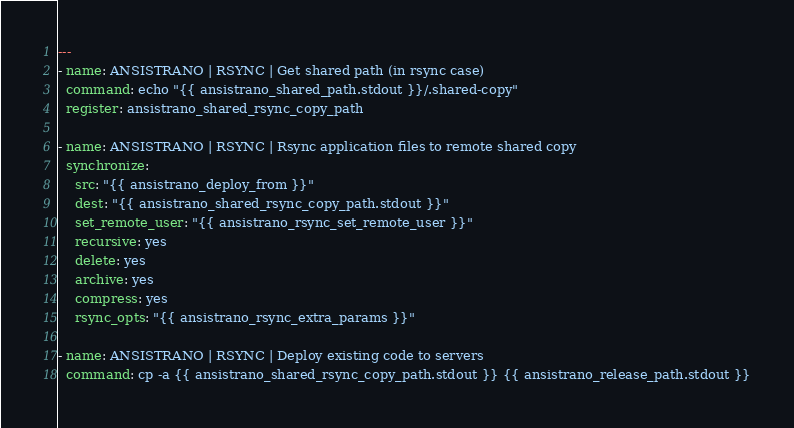<code> <loc_0><loc_0><loc_500><loc_500><_YAML_>---
- name: ANSISTRANO | RSYNC | Get shared path (in rsync case)
  command: echo "{{ ansistrano_shared_path.stdout }}/.shared-copy"
  register: ansistrano_shared_rsync_copy_path

- name: ANSISTRANO | RSYNC | Rsync application files to remote shared copy
  synchronize:
    src: "{{ ansistrano_deploy_from }}"
    dest: "{{ ansistrano_shared_rsync_copy_path.stdout }}"
    set_remote_user: "{{ ansistrano_rsync_set_remote_user }}"
    recursive: yes
    delete: yes
    archive: yes
    compress: yes
    rsync_opts: "{{ ansistrano_rsync_extra_params }}"

- name: ANSISTRANO | RSYNC | Deploy existing code to servers
  command: cp -a {{ ansistrano_shared_rsync_copy_path.stdout }} {{ ansistrano_release_path.stdout }}
</code> 